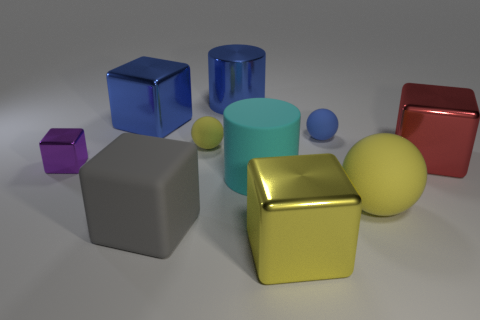There is a shiny block that is the same color as the metal cylinder; what size is it?
Give a very brief answer. Large. What size is the purple block that is made of the same material as the big red object?
Make the answer very short. Small. What is the shape of the big yellow object that is behind the big matte thing that is in front of the yellow matte sphere to the right of the big yellow metal thing?
Your answer should be compact. Sphere. What size is the blue metal object that is the same shape as the purple object?
Your answer should be compact. Large. What is the size of the shiny block that is both in front of the tiny yellow ball and to the left of the large yellow shiny thing?
Give a very brief answer. Small. What shape is the big metal thing that is the same color as the big ball?
Give a very brief answer. Cube. The small cube is what color?
Provide a short and direct response. Purple. What size is the metallic block that is in front of the large gray thing?
Provide a succinct answer. Large. What number of red metallic cubes are in front of the yellow matte thing that is in front of the big block to the right of the large matte ball?
Ensure brevity in your answer.  0. There is a large cube that is on the right side of the yellow metallic thing in front of the big red metal cube; what is its color?
Provide a short and direct response. Red. 